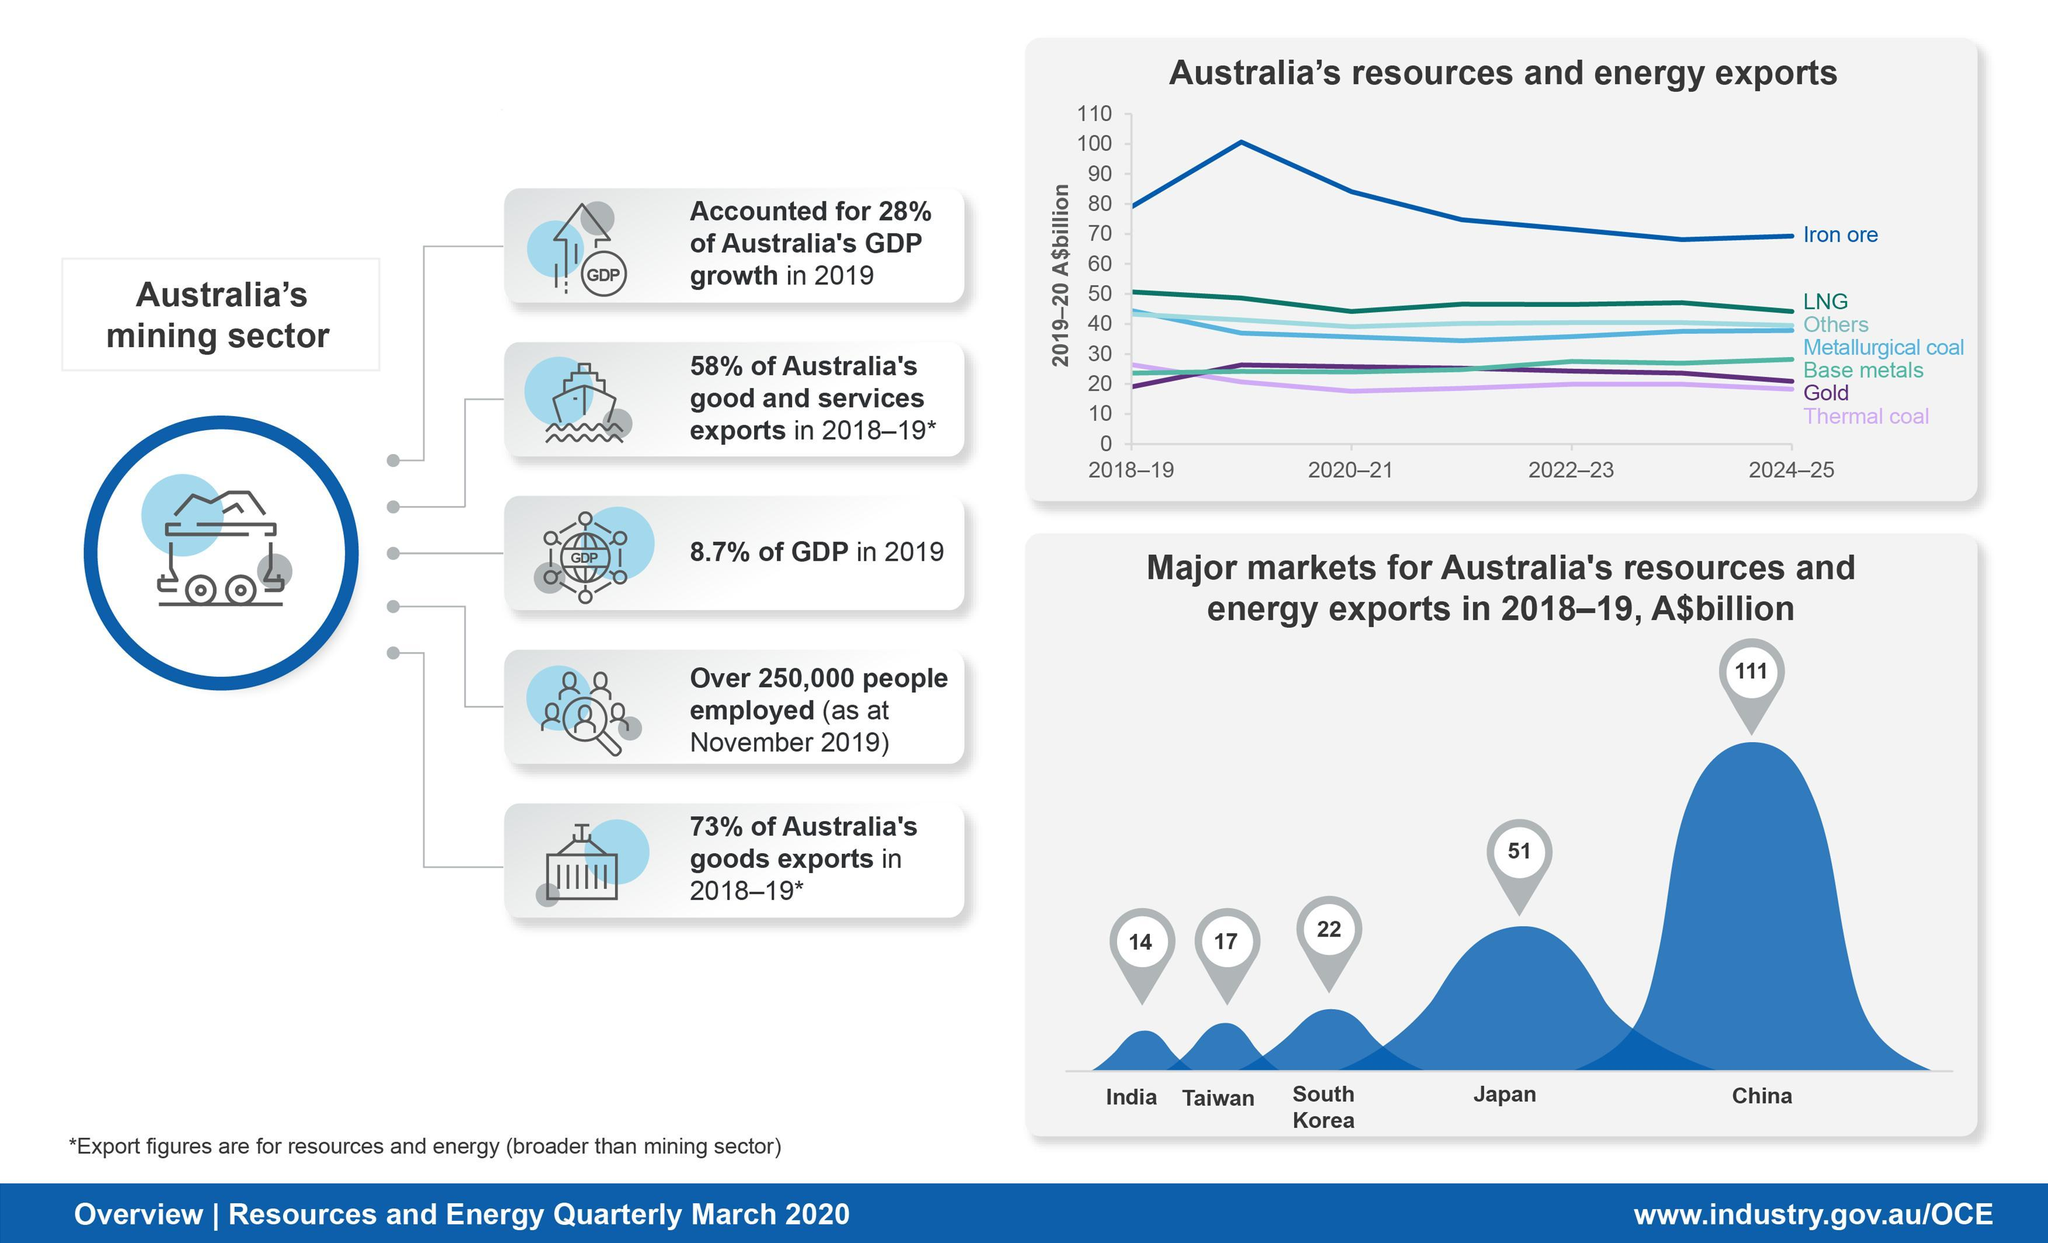What percent of the Australia's GDP is contributed by the mining sector in 2019?
Answer the question with a short phrase. 8.7% What is the value of Australia's resources & energy exports (in A$billion) to China during 2018-19? 111 What is the value of Australia's resources & energy exports (in A$billion) to Japan in 2018-19? 51 What is the value of Australia's resources & energy exports (in A$billion) to Taiwan during 2018-19? 17 What percent of the Australia's goods export is contributed by the mining sector in 2018-2019? 73% Which country is the top importer of Australia's resources & energy in 2018-2019? China 